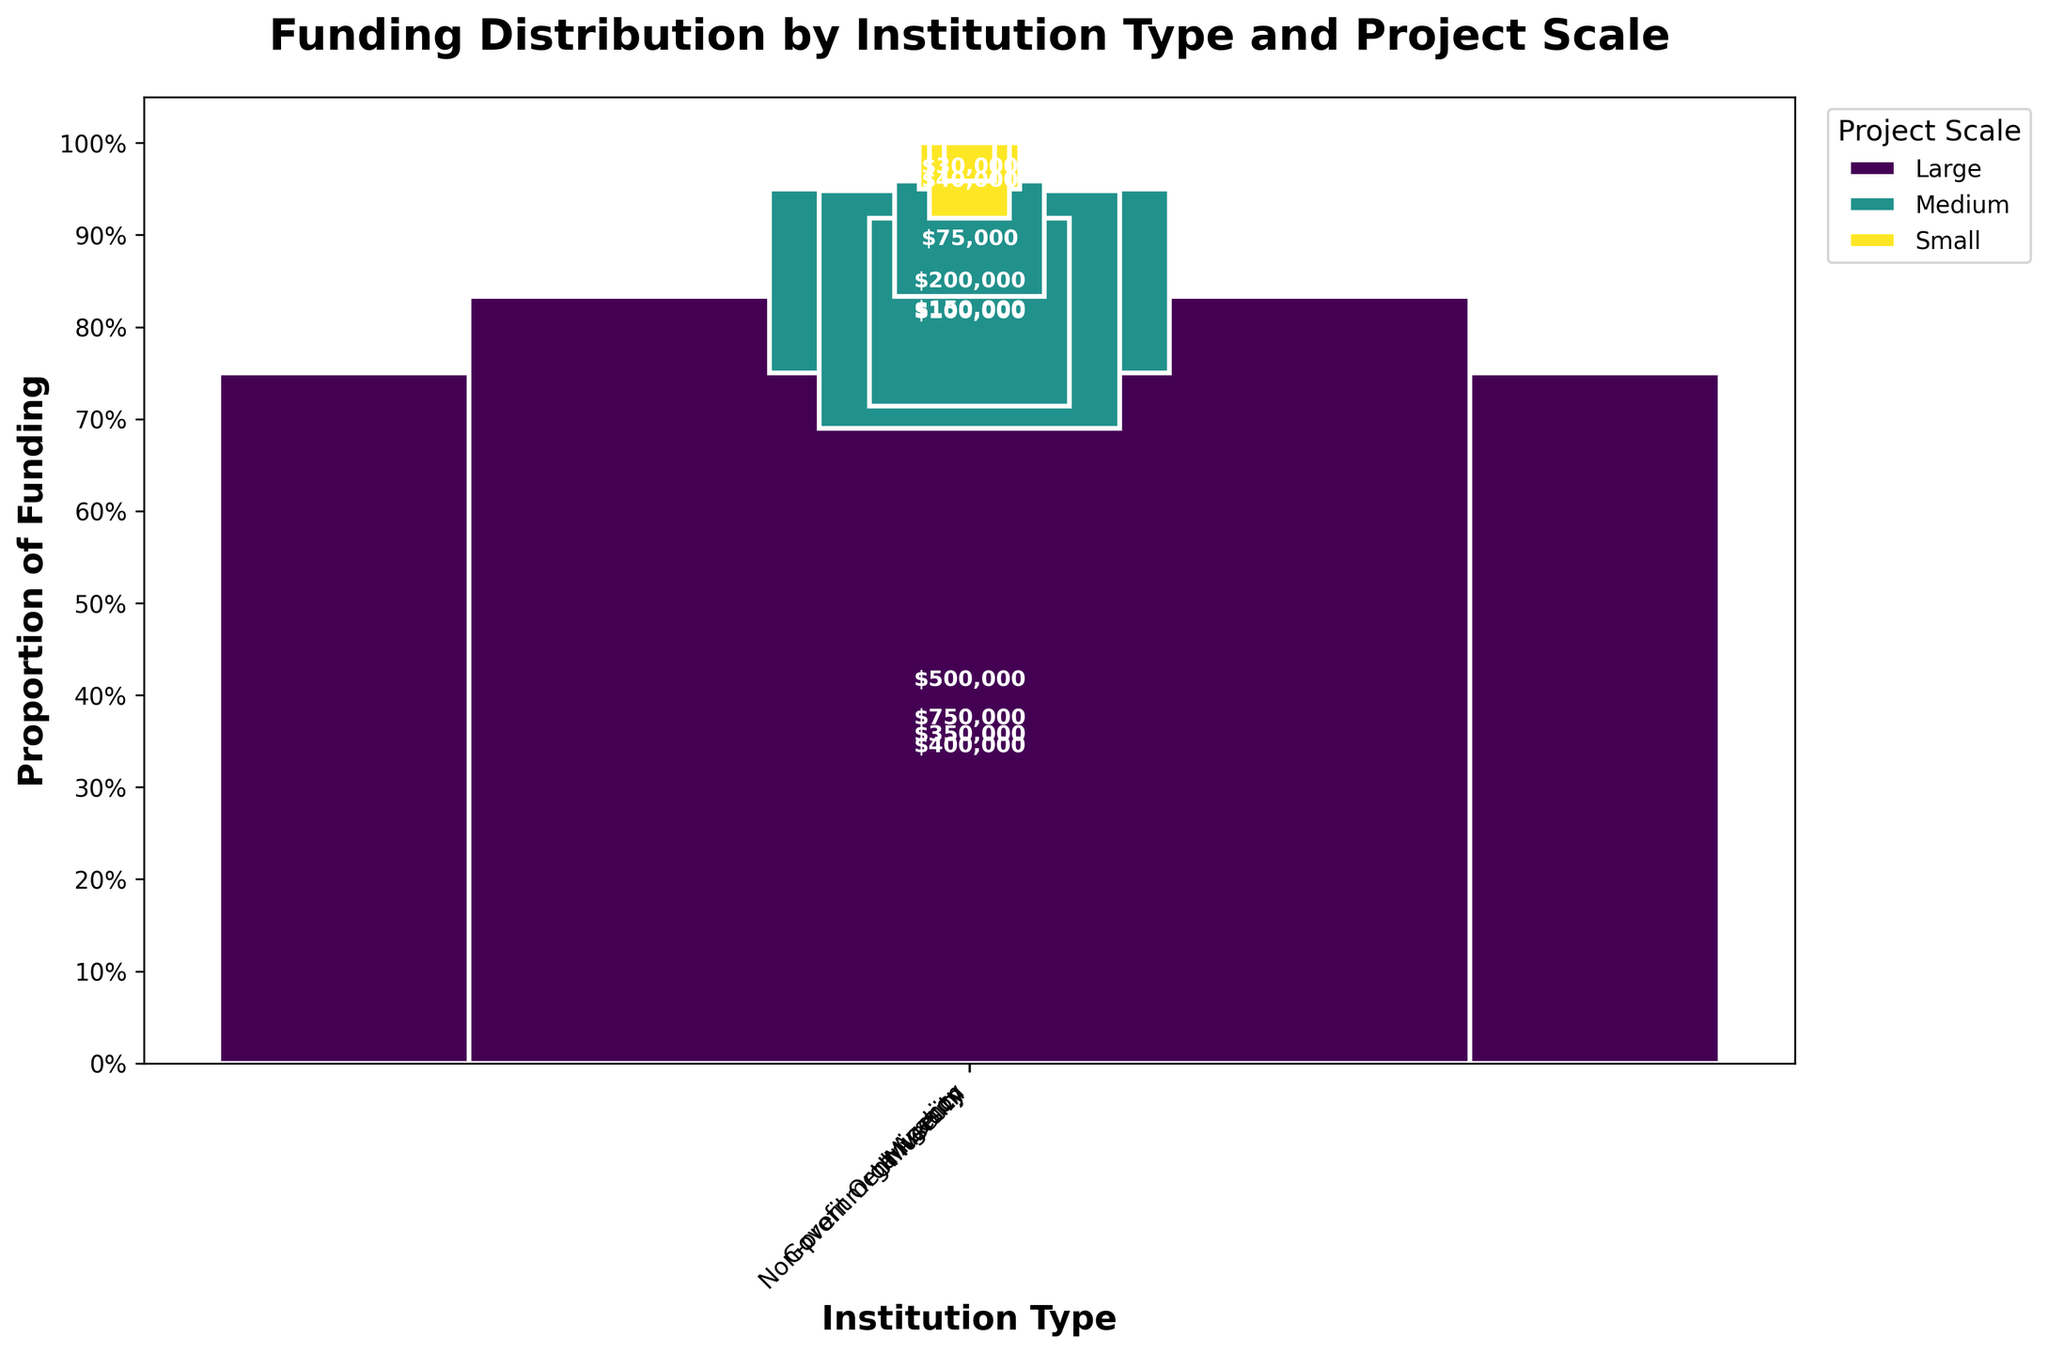Which project scale is most prominently funded by universities according to the plot? Look at the section of the mosaic plot corresponding to universities and identify which project scale (indicated by color) has the largest proportion.
Answer: Large What is the total funding amount for large-scale projects across all institution types? Sum the amounts in the "Large" project scale category for each institution type: ($500,000 + $400,000 + $750,000 + $350,000).
Answer: $2,000,000 Which institution type has the highest proportion of small-scale project funding compared to others? Compare the proportions of small-scale project funding for each institution type by looking at the relative sizes of the segments in the "Small" project scale category.
Answer: Hospitals How does the proportion of medium-scale projects for government agencies compare to universities? Compare the heights of the segments under the "Medium" project scale for government agencies and universities.
Answer: Higher in government agencies Which funding source contributes the most to non-profit organizations' large-scale projects? Identify the funding source linked with non-profit organizations' large-scale projects in the dataset summary.
Answer: National Geographic Society How does the total funding amount for medium-scale projects for museums compare to that for universities? Add the medium-scale project funding amounts for museums ($150,000) and universities ($75,000) and compare the sums.
Answer: Higher for museums What is the proportion of large-scale projects in the total funding for government agencies? Calculate the proportion by dividing the amount for large-scale projects ($750,000) by the total funding across scales for government agencies ($750,000 + $200,000 + $50,000).
Answer: 75% Which institution type receives the least total funding for all scales combined? Sum the amounts for all scales across each institution type and identify the smallest total.
Answer: Non-profit Organization 